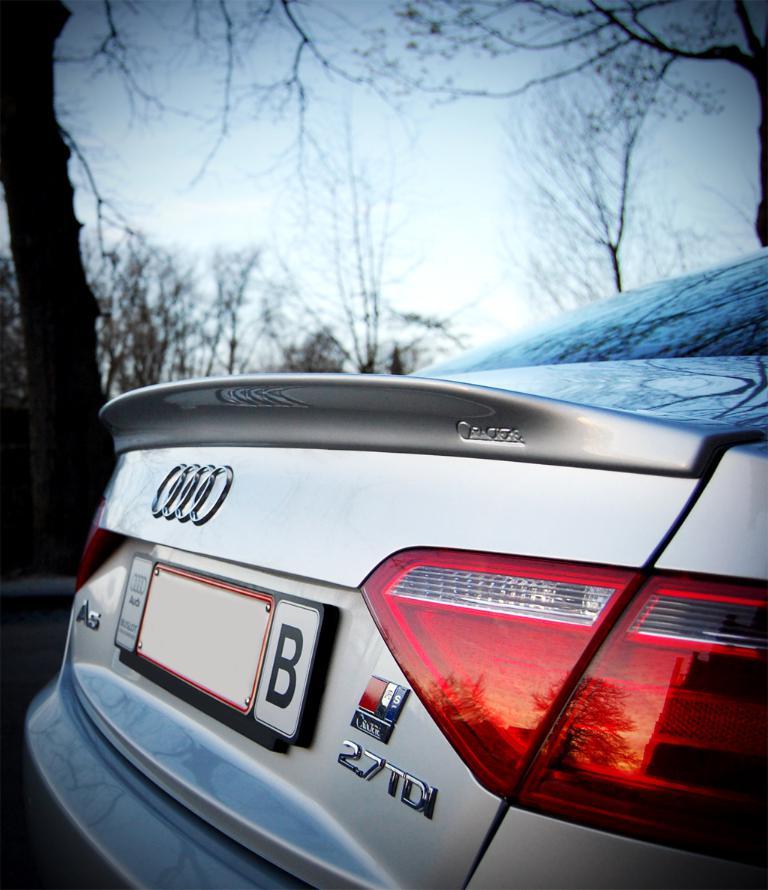What single letter is next to the license plate?
Make the answer very short. B. Is this car and audi?
Your answer should be compact. Yes. 